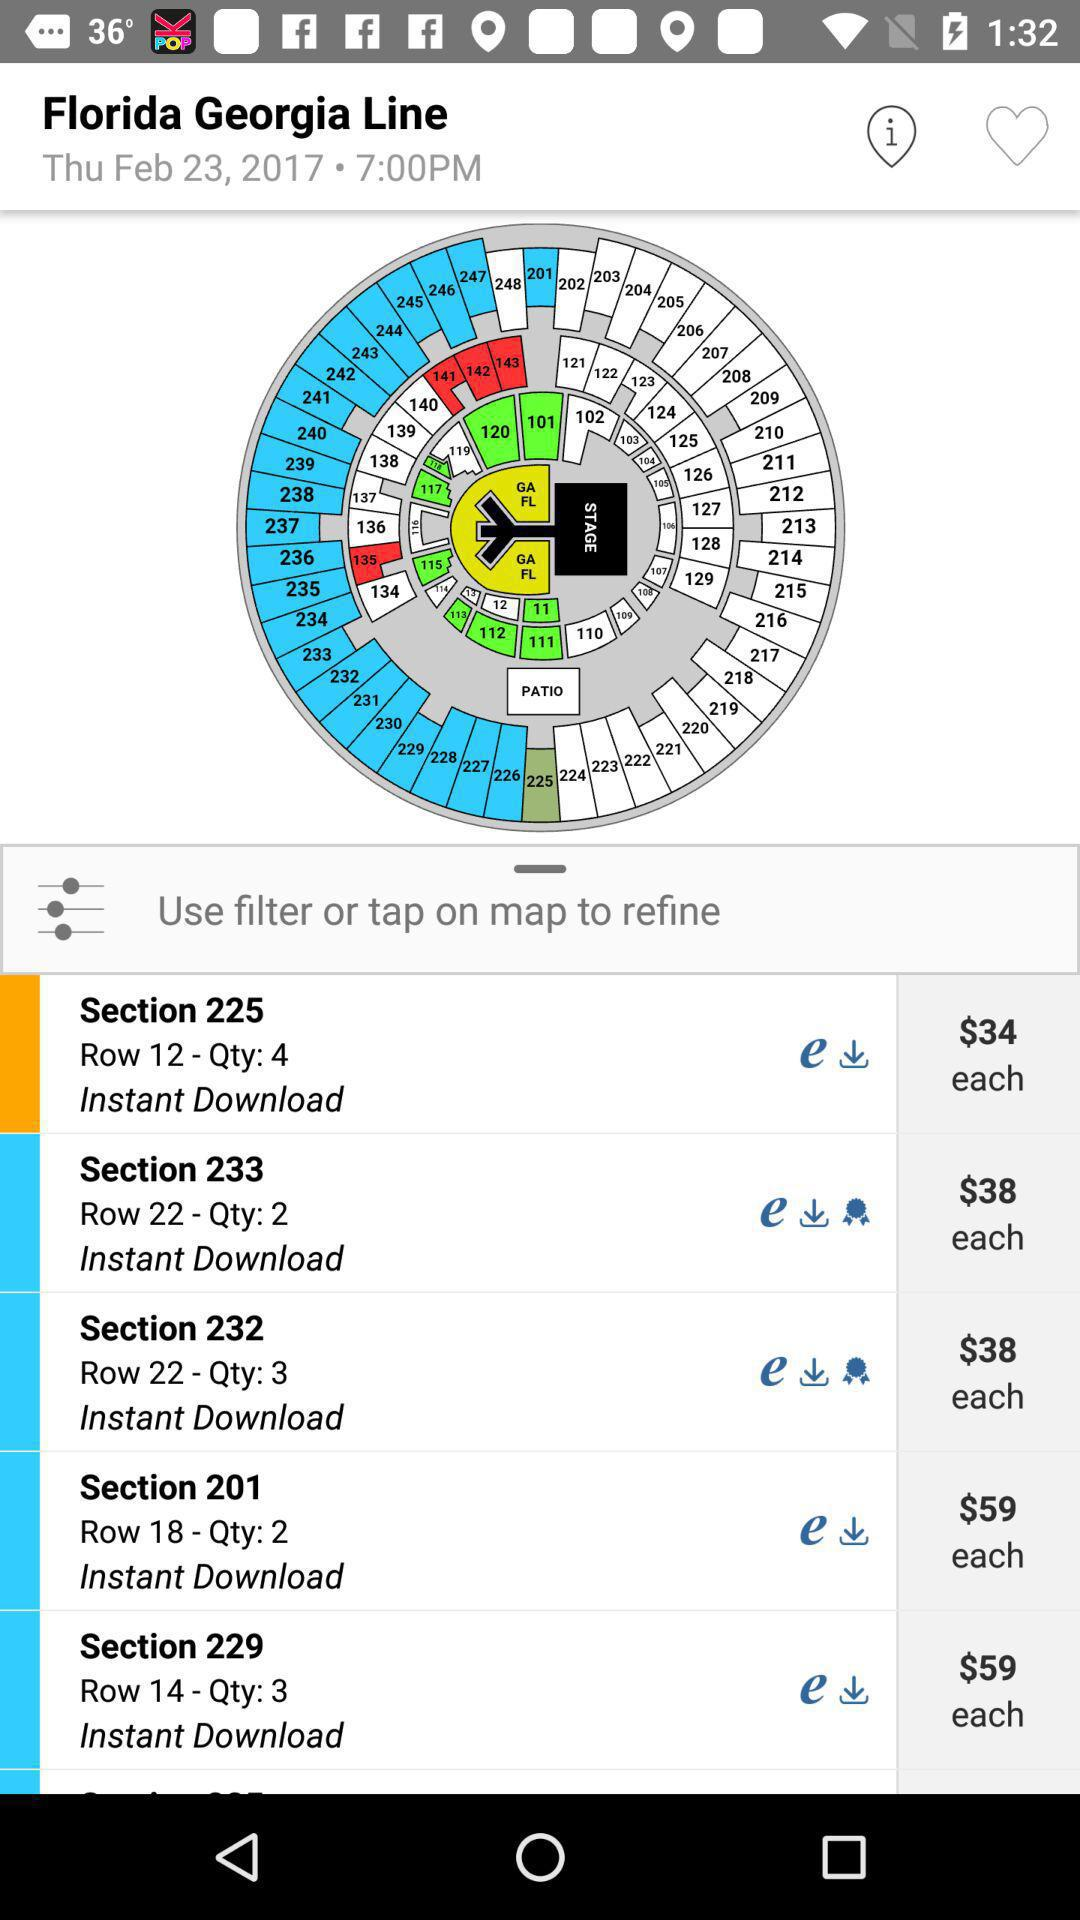How much more does a ticket in section 233 cost than a ticket in section 201?
Answer the question using a single word or phrase. $21 